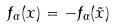Convert formula to latex. <formula><loc_0><loc_0><loc_500><loc_500>f _ { \alpha } ( x ) = - f _ { \alpha } ( \tilde { x } )</formula> 